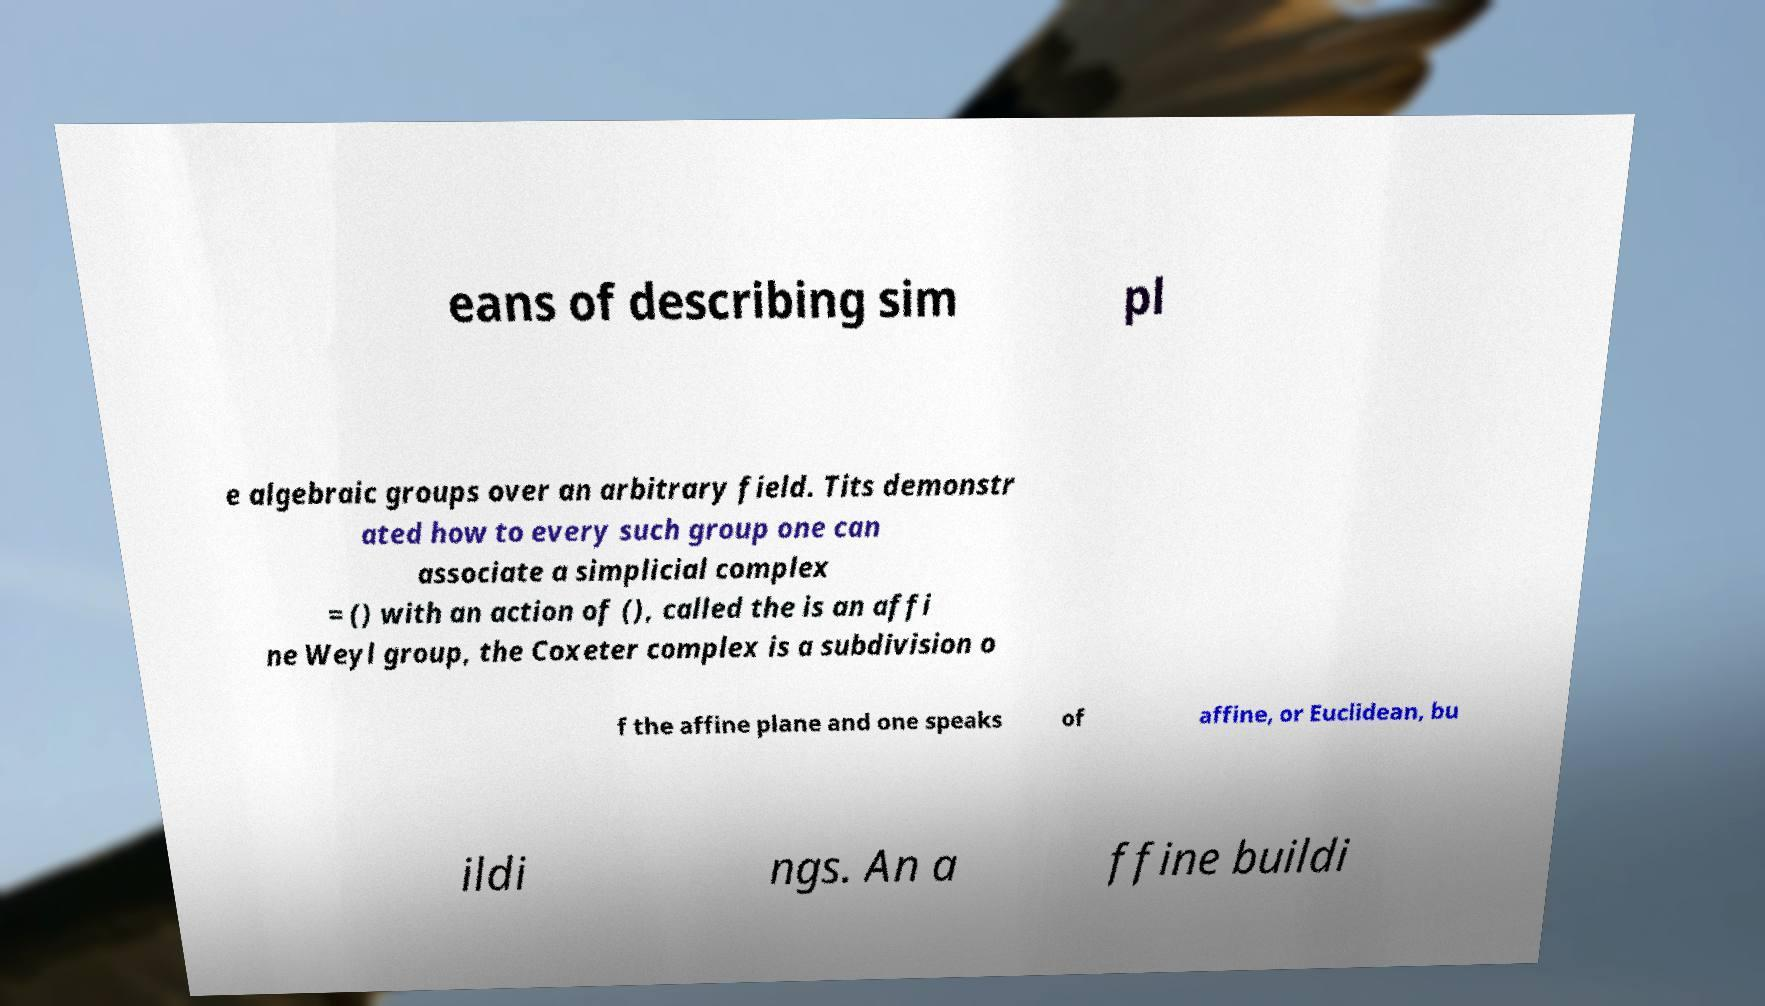What messages or text are displayed in this image? I need them in a readable, typed format. eans of describing sim pl e algebraic groups over an arbitrary field. Tits demonstr ated how to every such group one can associate a simplicial complex = () with an action of (), called the is an affi ne Weyl group, the Coxeter complex is a subdivision o f the affine plane and one speaks of affine, or Euclidean, bu ildi ngs. An a ffine buildi 